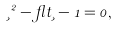<formula> <loc_0><loc_0><loc_500><loc_500>\xi ^ { 2 } - \gamma t \xi - 1 = 0 ,</formula> 